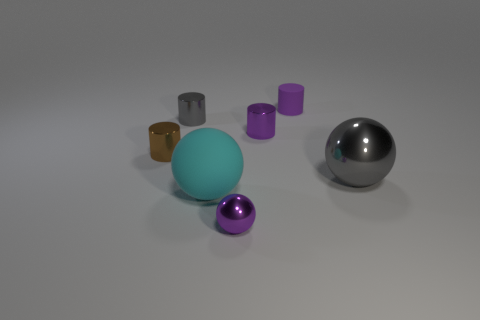Subtract all shiny balls. How many balls are left? 1 Subtract all gray cylinders. How many cylinders are left? 3 Add 6 gray metal spheres. How many gray metal spheres exist? 7 Add 3 big green blocks. How many objects exist? 10 Subtract 0 brown balls. How many objects are left? 7 Subtract all cylinders. How many objects are left? 3 Subtract 1 cylinders. How many cylinders are left? 3 Subtract all cyan balls. Subtract all green cubes. How many balls are left? 2 Subtract all blue blocks. How many purple balls are left? 1 Subtract all small gray metallic cylinders. Subtract all big cyan spheres. How many objects are left? 5 